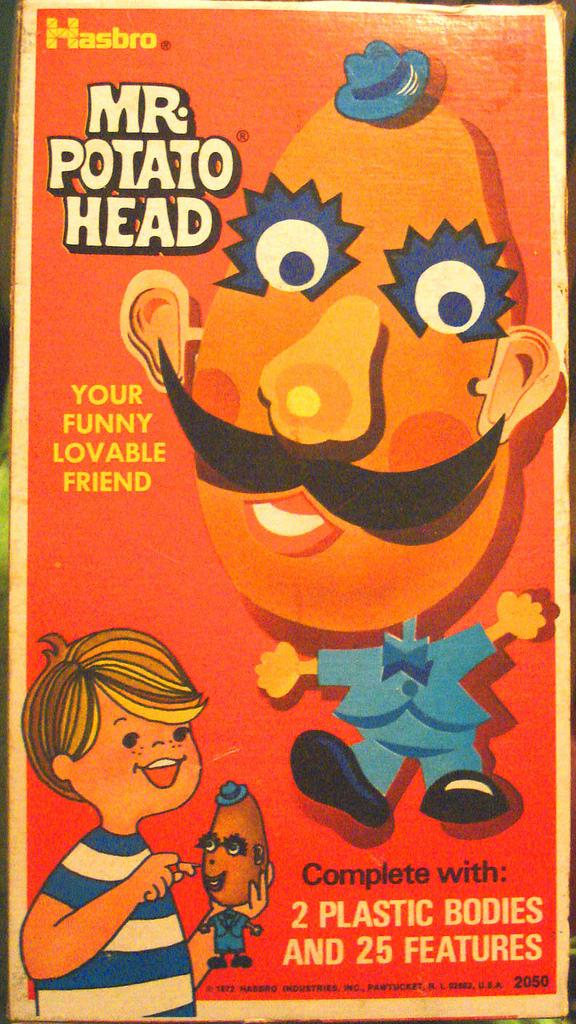<image>
Create a compact narrative representing the image presented. The box for the Mr. Potato Head toy from Hasbro. 